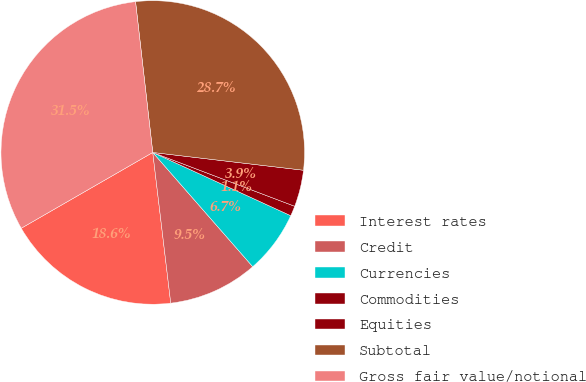Convert chart. <chart><loc_0><loc_0><loc_500><loc_500><pie_chart><fcel>Interest rates<fcel>Credit<fcel>Currencies<fcel>Commodities<fcel>Equities<fcel>Subtotal<fcel>Gross fair value/notional<nl><fcel>18.57%<fcel>9.55%<fcel>6.72%<fcel>1.07%<fcel>3.9%<fcel>28.68%<fcel>31.51%<nl></chart> 